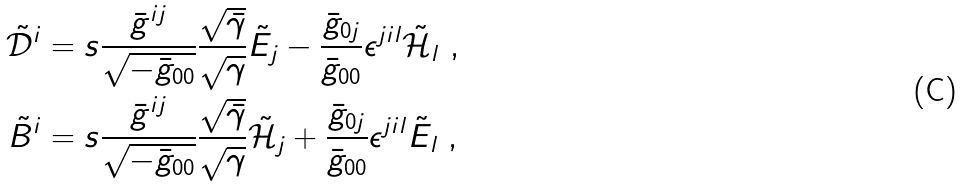Convert formula to latex. <formula><loc_0><loc_0><loc_500><loc_500>\tilde { \mathcal { D } } ^ { i } & = s \frac { \bar { g } ^ { i j } } { \sqrt { - \bar { g } _ { 0 0 } } } \frac { \sqrt { \bar { \gamma } } } { \sqrt { \gamma } } \tilde { E } _ { j } - \frac { \bar { g } _ { 0 j } } { \bar { g } _ { 0 0 } } \epsilon ^ { j i l } \tilde { \mathcal { H } } _ { l } \ , \\ \tilde { B } ^ { i } & = s \frac { \bar { g } ^ { i j } } { \sqrt { - \bar { g } _ { 0 0 } } } \frac { \sqrt { \bar { \gamma } } } { \sqrt { \gamma } } \tilde { \mathcal { H } } _ { j } + \frac { \bar { g } _ { 0 j } } { \bar { g } _ { 0 0 } } \epsilon ^ { j i l } \tilde { E } _ { l } \ ,</formula> 